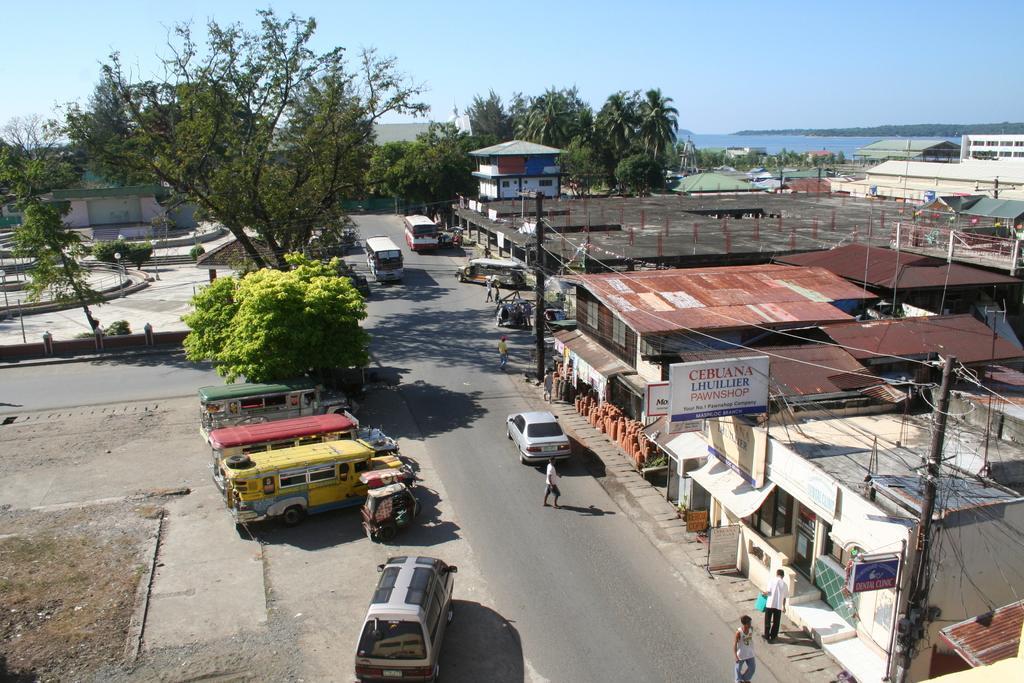Please provide a concise description of this image. On the left side, there are vehicles and trees on a ground. On the right side, there are vehicles and persons on a road, there is a person on a footpath, there are electric poles and buildings. In the background, there are buildings, trees, water and there are clouds in the blue sky. 